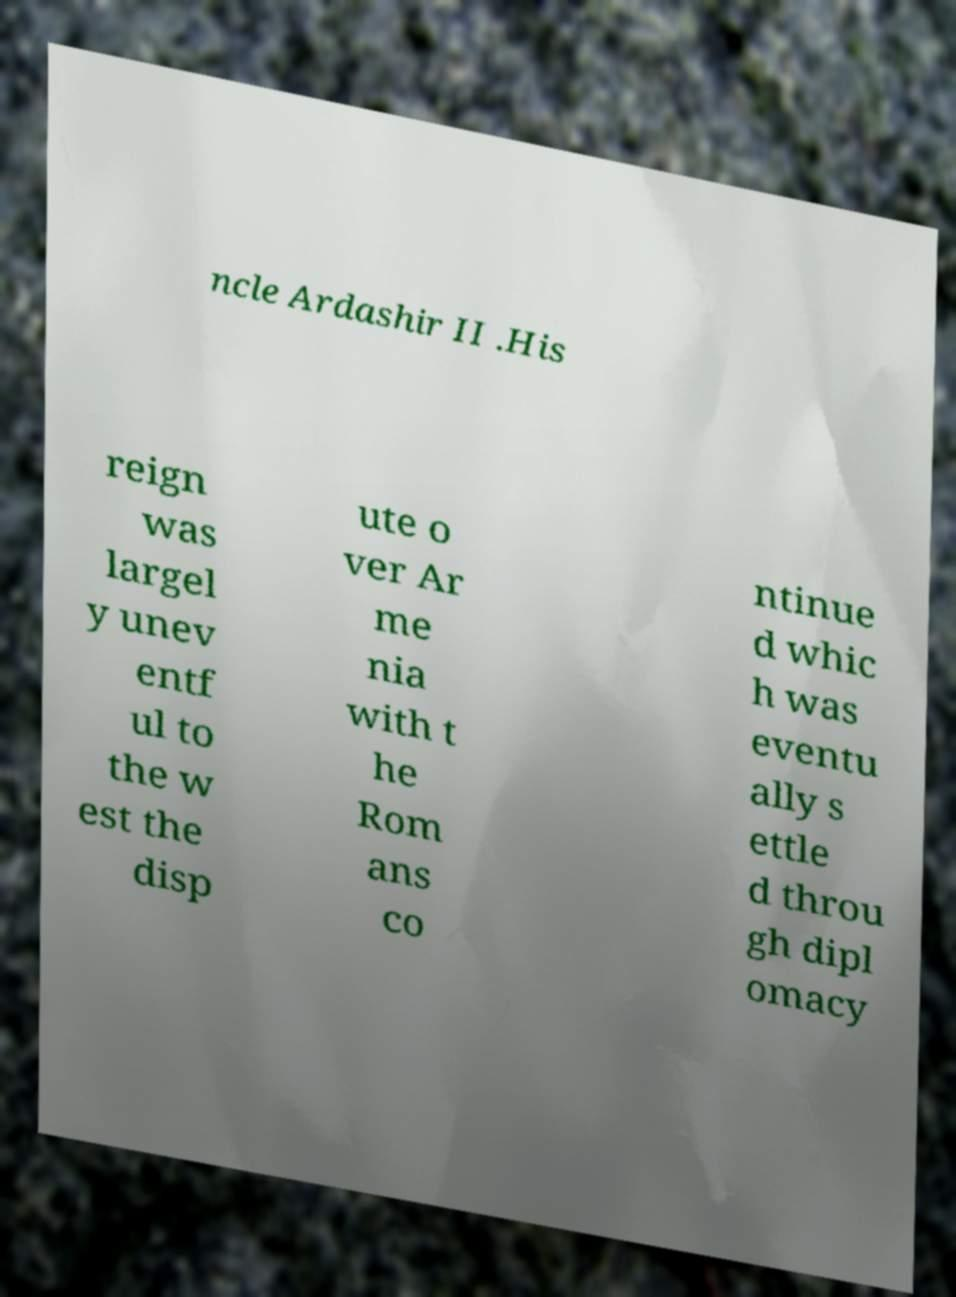I need the written content from this picture converted into text. Can you do that? ncle Ardashir II .His reign was largel y unev entf ul to the w est the disp ute o ver Ar me nia with t he Rom ans co ntinue d whic h was eventu ally s ettle d throu gh dipl omacy 